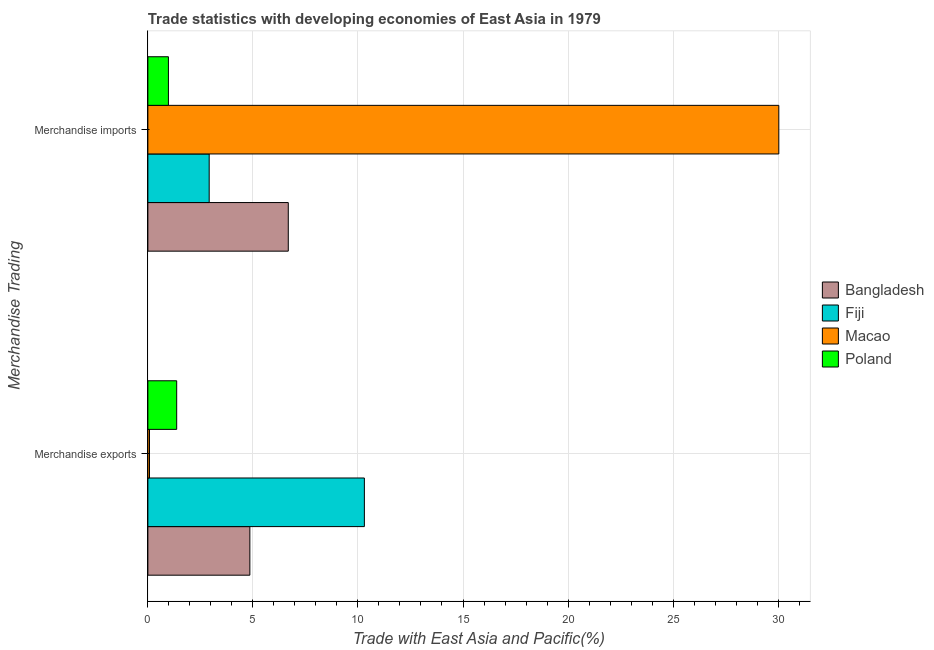How many different coloured bars are there?
Ensure brevity in your answer.  4. Are the number of bars on each tick of the Y-axis equal?
Ensure brevity in your answer.  Yes. How many bars are there on the 2nd tick from the top?
Offer a very short reply. 4. What is the merchandise exports in Fiji?
Provide a short and direct response. 10.31. Across all countries, what is the maximum merchandise imports?
Your answer should be very brief. 30.03. Across all countries, what is the minimum merchandise exports?
Keep it short and to the point. 0.08. In which country was the merchandise exports maximum?
Your response must be concise. Fiji. In which country was the merchandise exports minimum?
Your answer should be compact. Macao. What is the total merchandise exports in the graph?
Your answer should be very brief. 16.61. What is the difference between the merchandise exports in Poland and that in Fiji?
Give a very brief answer. -8.93. What is the difference between the merchandise exports in Fiji and the merchandise imports in Macao?
Make the answer very short. -19.73. What is the average merchandise exports per country?
Your response must be concise. 4.15. What is the difference between the merchandise imports and merchandise exports in Fiji?
Your answer should be very brief. -7.39. What is the ratio of the merchandise imports in Macao to that in Fiji?
Ensure brevity in your answer.  10.29. Is the merchandise exports in Poland less than that in Bangladesh?
Provide a succinct answer. Yes. What does the 4th bar from the top in Merchandise imports represents?
Offer a very short reply. Bangladesh. How many countries are there in the graph?
Make the answer very short. 4. What is the difference between two consecutive major ticks on the X-axis?
Provide a succinct answer. 5. Are the values on the major ticks of X-axis written in scientific E-notation?
Your response must be concise. No. Does the graph contain grids?
Make the answer very short. Yes. Where does the legend appear in the graph?
Your answer should be compact. Center right. How are the legend labels stacked?
Give a very brief answer. Vertical. What is the title of the graph?
Provide a succinct answer. Trade statistics with developing economies of East Asia in 1979. Does "East Asia (all income levels)" appear as one of the legend labels in the graph?
Give a very brief answer. No. What is the label or title of the X-axis?
Make the answer very short. Trade with East Asia and Pacific(%). What is the label or title of the Y-axis?
Provide a succinct answer. Merchandise Trading. What is the Trade with East Asia and Pacific(%) of Bangladesh in Merchandise exports?
Keep it short and to the point. 4.85. What is the Trade with East Asia and Pacific(%) in Fiji in Merchandise exports?
Give a very brief answer. 10.31. What is the Trade with East Asia and Pacific(%) of Macao in Merchandise exports?
Keep it short and to the point. 0.08. What is the Trade with East Asia and Pacific(%) in Poland in Merchandise exports?
Provide a succinct answer. 1.37. What is the Trade with East Asia and Pacific(%) of Bangladesh in Merchandise imports?
Offer a very short reply. 6.68. What is the Trade with East Asia and Pacific(%) of Fiji in Merchandise imports?
Make the answer very short. 2.92. What is the Trade with East Asia and Pacific(%) of Macao in Merchandise imports?
Your response must be concise. 30.03. What is the Trade with East Asia and Pacific(%) of Poland in Merchandise imports?
Keep it short and to the point. 0.98. Across all Merchandise Trading, what is the maximum Trade with East Asia and Pacific(%) of Bangladesh?
Make the answer very short. 6.68. Across all Merchandise Trading, what is the maximum Trade with East Asia and Pacific(%) of Fiji?
Give a very brief answer. 10.31. Across all Merchandise Trading, what is the maximum Trade with East Asia and Pacific(%) of Macao?
Provide a succinct answer. 30.03. Across all Merchandise Trading, what is the maximum Trade with East Asia and Pacific(%) of Poland?
Provide a succinct answer. 1.37. Across all Merchandise Trading, what is the minimum Trade with East Asia and Pacific(%) in Bangladesh?
Your response must be concise. 4.85. Across all Merchandise Trading, what is the minimum Trade with East Asia and Pacific(%) of Fiji?
Provide a succinct answer. 2.92. Across all Merchandise Trading, what is the minimum Trade with East Asia and Pacific(%) in Macao?
Keep it short and to the point. 0.08. Across all Merchandise Trading, what is the minimum Trade with East Asia and Pacific(%) in Poland?
Your response must be concise. 0.98. What is the total Trade with East Asia and Pacific(%) of Bangladesh in the graph?
Offer a very short reply. 11.54. What is the total Trade with East Asia and Pacific(%) of Fiji in the graph?
Make the answer very short. 13.22. What is the total Trade with East Asia and Pacific(%) of Macao in the graph?
Your answer should be compact. 30.11. What is the total Trade with East Asia and Pacific(%) of Poland in the graph?
Keep it short and to the point. 2.35. What is the difference between the Trade with East Asia and Pacific(%) of Bangladesh in Merchandise exports and that in Merchandise imports?
Ensure brevity in your answer.  -1.83. What is the difference between the Trade with East Asia and Pacific(%) in Fiji in Merchandise exports and that in Merchandise imports?
Your answer should be very brief. 7.39. What is the difference between the Trade with East Asia and Pacific(%) of Macao in Merchandise exports and that in Merchandise imports?
Keep it short and to the point. -29.96. What is the difference between the Trade with East Asia and Pacific(%) of Poland in Merchandise exports and that in Merchandise imports?
Your answer should be very brief. 0.39. What is the difference between the Trade with East Asia and Pacific(%) of Bangladesh in Merchandise exports and the Trade with East Asia and Pacific(%) of Fiji in Merchandise imports?
Your response must be concise. 1.94. What is the difference between the Trade with East Asia and Pacific(%) of Bangladesh in Merchandise exports and the Trade with East Asia and Pacific(%) of Macao in Merchandise imports?
Your answer should be very brief. -25.18. What is the difference between the Trade with East Asia and Pacific(%) in Bangladesh in Merchandise exports and the Trade with East Asia and Pacific(%) in Poland in Merchandise imports?
Your answer should be compact. 3.88. What is the difference between the Trade with East Asia and Pacific(%) in Fiji in Merchandise exports and the Trade with East Asia and Pacific(%) in Macao in Merchandise imports?
Your answer should be very brief. -19.73. What is the difference between the Trade with East Asia and Pacific(%) in Fiji in Merchandise exports and the Trade with East Asia and Pacific(%) in Poland in Merchandise imports?
Offer a very short reply. 9.33. What is the difference between the Trade with East Asia and Pacific(%) in Macao in Merchandise exports and the Trade with East Asia and Pacific(%) in Poland in Merchandise imports?
Give a very brief answer. -0.9. What is the average Trade with East Asia and Pacific(%) in Bangladesh per Merchandise Trading?
Make the answer very short. 5.77. What is the average Trade with East Asia and Pacific(%) in Fiji per Merchandise Trading?
Your answer should be very brief. 6.61. What is the average Trade with East Asia and Pacific(%) in Macao per Merchandise Trading?
Your response must be concise. 15.06. What is the average Trade with East Asia and Pacific(%) of Poland per Merchandise Trading?
Make the answer very short. 1.18. What is the difference between the Trade with East Asia and Pacific(%) in Bangladesh and Trade with East Asia and Pacific(%) in Fiji in Merchandise exports?
Offer a very short reply. -5.45. What is the difference between the Trade with East Asia and Pacific(%) of Bangladesh and Trade with East Asia and Pacific(%) of Macao in Merchandise exports?
Give a very brief answer. 4.78. What is the difference between the Trade with East Asia and Pacific(%) of Bangladesh and Trade with East Asia and Pacific(%) of Poland in Merchandise exports?
Your response must be concise. 3.48. What is the difference between the Trade with East Asia and Pacific(%) of Fiji and Trade with East Asia and Pacific(%) of Macao in Merchandise exports?
Your answer should be very brief. 10.23. What is the difference between the Trade with East Asia and Pacific(%) in Fiji and Trade with East Asia and Pacific(%) in Poland in Merchandise exports?
Ensure brevity in your answer.  8.93. What is the difference between the Trade with East Asia and Pacific(%) in Macao and Trade with East Asia and Pacific(%) in Poland in Merchandise exports?
Your response must be concise. -1.29. What is the difference between the Trade with East Asia and Pacific(%) in Bangladesh and Trade with East Asia and Pacific(%) in Fiji in Merchandise imports?
Your answer should be compact. 3.77. What is the difference between the Trade with East Asia and Pacific(%) of Bangladesh and Trade with East Asia and Pacific(%) of Macao in Merchandise imports?
Make the answer very short. -23.35. What is the difference between the Trade with East Asia and Pacific(%) in Bangladesh and Trade with East Asia and Pacific(%) in Poland in Merchandise imports?
Keep it short and to the point. 5.71. What is the difference between the Trade with East Asia and Pacific(%) of Fiji and Trade with East Asia and Pacific(%) of Macao in Merchandise imports?
Your response must be concise. -27.11. What is the difference between the Trade with East Asia and Pacific(%) in Fiji and Trade with East Asia and Pacific(%) in Poland in Merchandise imports?
Provide a short and direct response. 1.94. What is the difference between the Trade with East Asia and Pacific(%) in Macao and Trade with East Asia and Pacific(%) in Poland in Merchandise imports?
Offer a very short reply. 29.05. What is the ratio of the Trade with East Asia and Pacific(%) of Bangladesh in Merchandise exports to that in Merchandise imports?
Your response must be concise. 0.73. What is the ratio of the Trade with East Asia and Pacific(%) in Fiji in Merchandise exports to that in Merchandise imports?
Your answer should be very brief. 3.53. What is the ratio of the Trade with East Asia and Pacific(%) in Macao in Merchandise exports to that in Merchandise imports?
Ensure brevity in your answer.  0. What is the ratio of the Trade with East Asia and Pacific(%) of Poland in Merchandise exports to that in Merchandise imports?
Your response must be concise. 1.4. What is the difference between the highest and the second highest Trade with East Asia and Pacific(%) of Bangladesh?
Your answer should be compact. 1.83. What is the difference between the highest and the second highest Trade with East Asia and Pacific(%) of Fiji?
Give a very brief answer. 7.39. What is the difference between the highest and the second highest Trade with East Asia and Pacific(%) in Macao?
Offer a terse response. 29.96. What is the difference between the highest and the second highest Trade with East Asia and Pacific(%) in Poland?
Make the answer very short. 0.39. What is the difference between the highest and the lowest Trade with East Asia and Pacific(%) of Bangladesh?
Offer a terse response. 1.83. What is the difference between the highest and the lowest Trade with East Asia and Pacific(%) in Fiji?
Offer a terse response. 7.39. What is the difference between the highest and the lowest Trade with East Asia and Pacific(%) of Macao?
Offer a terse response. 29.96. What is the difference between the highest and the lowest Trade with East Asia and Pacific(%) in Poland?
Offer a terse response. 0.39. 